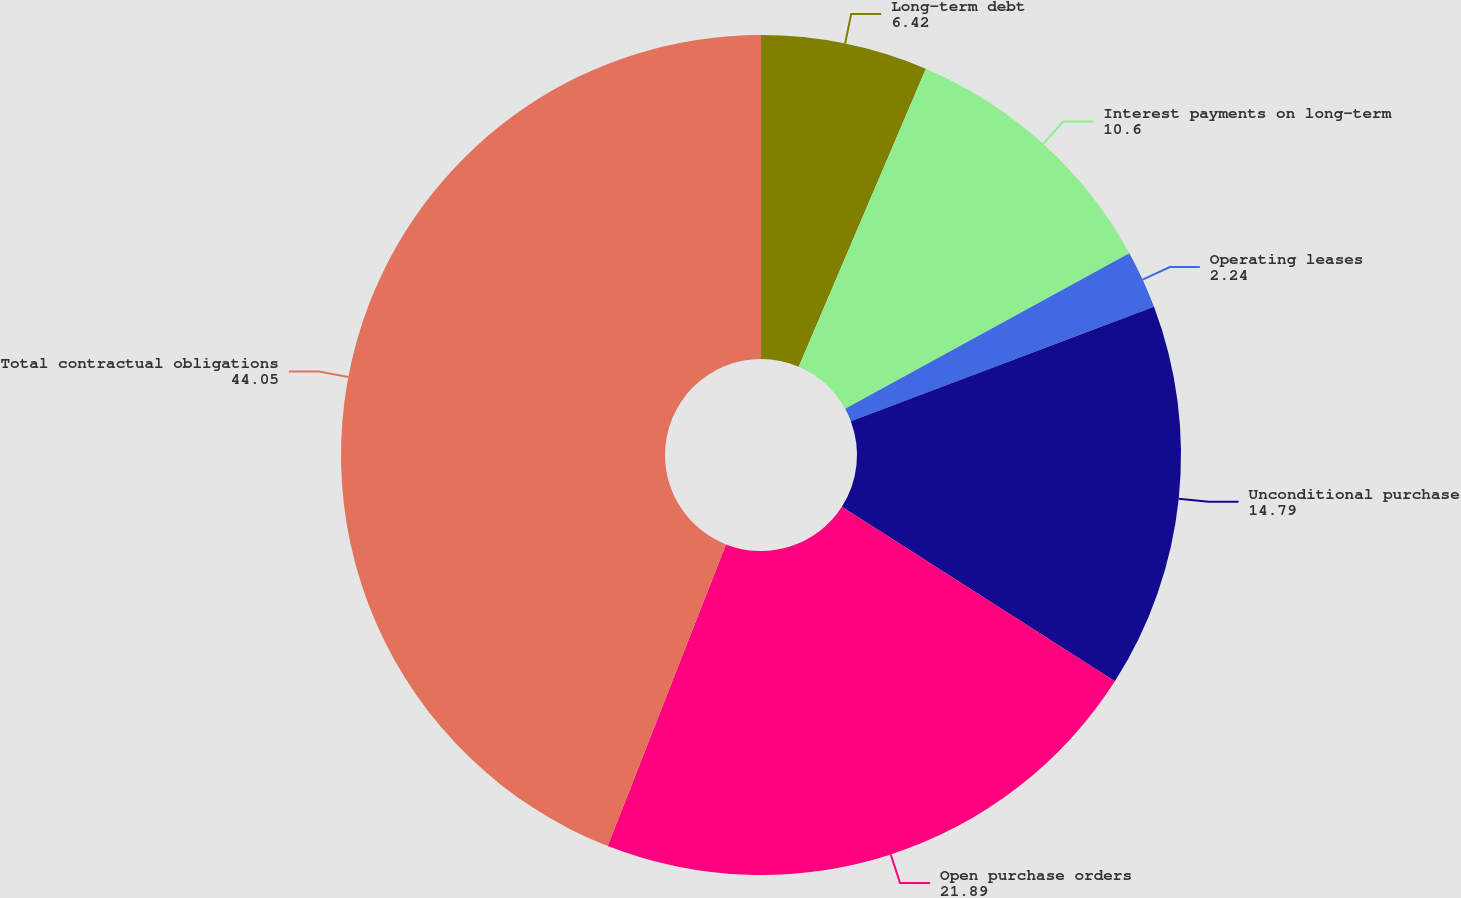<chart> <loc_0><loc_0><loc_500><loc_500><pie_chart><fcel>Long-term debt<fcel>Interest payments on long-term<fcel>Operating leases<fcel>Unconditional purchase<fcel>Open purchase orders<fcel>Total contractual obligations<nl><fcel>6.42%<fcel>10.6%<fcel>2.24%<fcel>14.79%<fcel>21.89%<fcel>44.05%<nl></chart> 